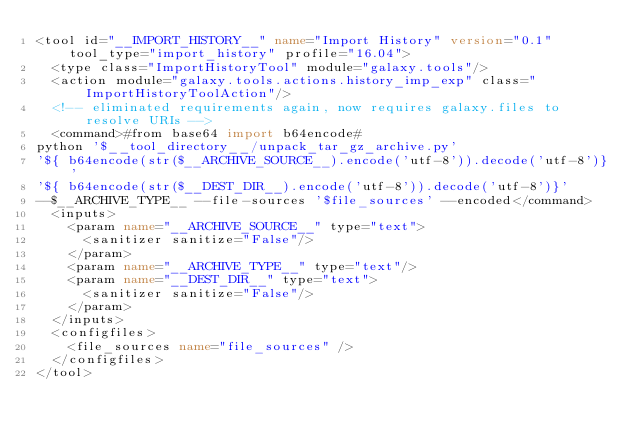Convert code to text. <code><loc_0><loc_0><loc_500><loc_500><_XML_><tool id="__IMPORT_HISTORY__" name="Import History" version="0.1" tool_type="import_history" profile="16.04">
  <type class="ImportHistoryTool" module="galaxy.tools"/>
  <action module="galaxy.tools.actions.history_imp_exp" class="ImportHistoryToolAction"/>
  <!-- eliminated requirements again, now requires galaxy.files to resolve URIs -->
  <command>#from base64 import b64encode#
python '$__tool_directory__/unpack_tar_gz_archive.py'
'${ b64encode(str($__ARCHIVE_SOURCE__).encode('utf-8')).decode('utf-8')}'
'${ b64encode(str($__DEST_DIR__).encode('utf-8')).decode('utf-8')}'
--$__ARCHIVE_TYPE__ --file-sources '$file_sources' --encoded</command>
  <inputs>
    <param name="__ARCHIVE_SOURCE__" type="text">
      <sanitizer sanitize="False"/>
    </param>
    <param name="__ARCHIVE_TYPE__" type="text"/>
    <param name="__DEST_DIR__" type="text">
      <sanitizer sanitize="False"/>
    </param>
  </inputs>
  <configfiles>
    <file_sources name="file_sources" />
  </configfiles>
</tool>
</code> 